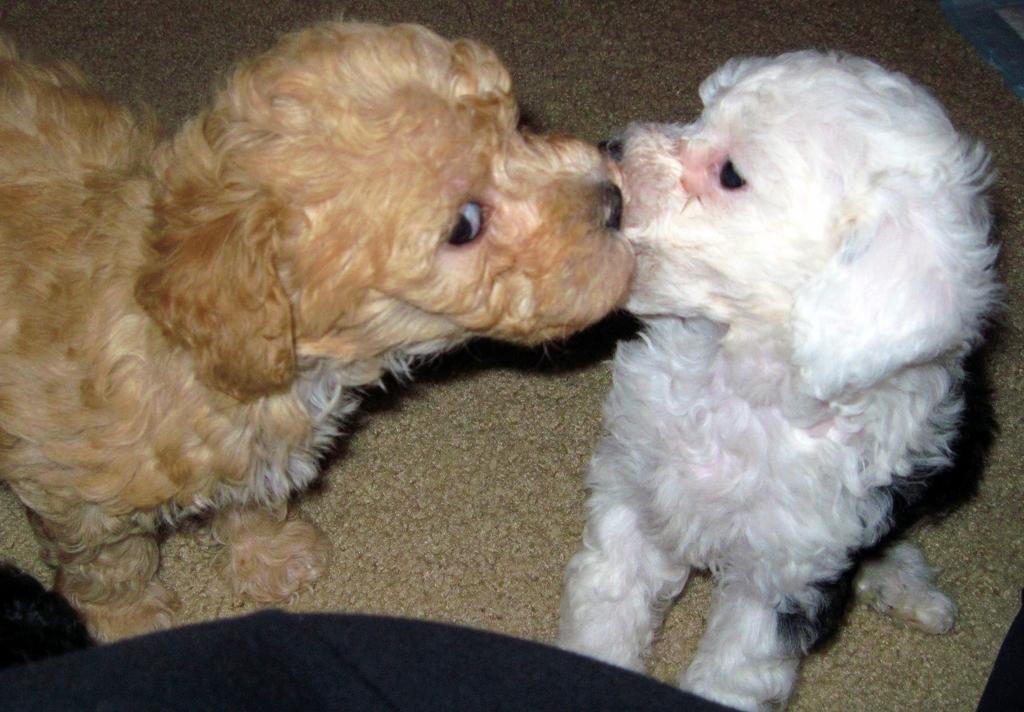Please provide a concise description of this image. In this image we can see white and brown color dogs on the carpet. 